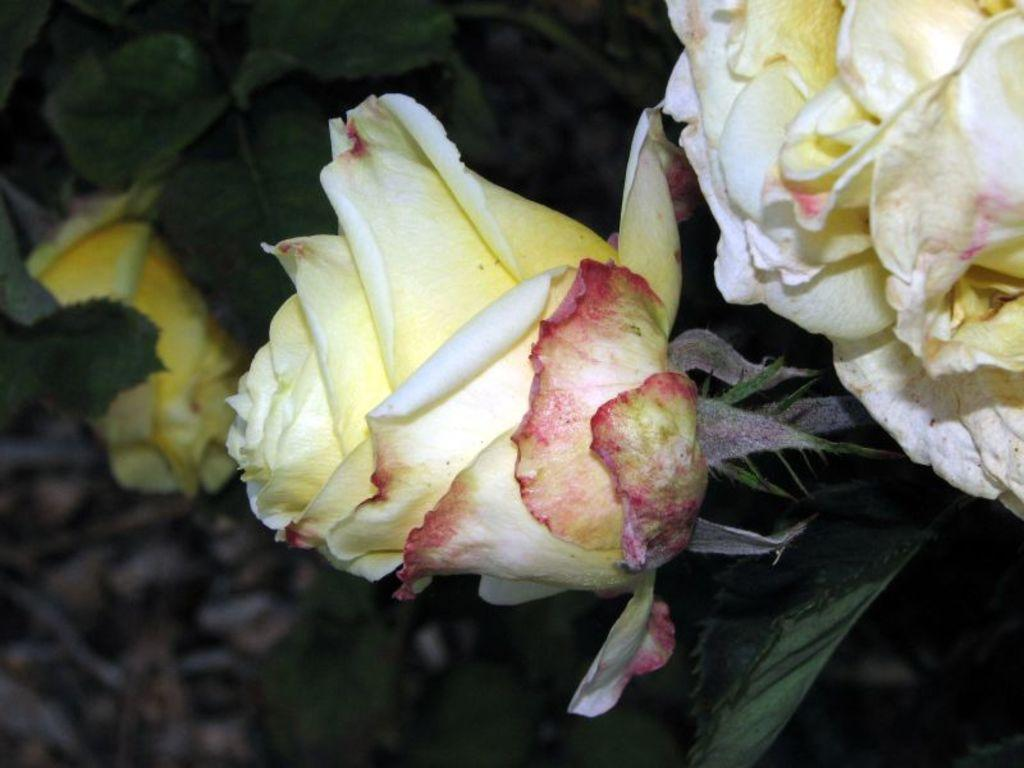What type of plant life is present in the image? There are flowers with stems and leaves in the image. Where are the flowers located in the image? The flowers are in the middle of the image. What else can be seen in the background of the image? There are other leaves visible in the background of the image. What type of engine is visible in the image? There is no engine present in the image; it features flowers and leaves. What kind of discussion is taking place in the image? There is no discussion taking place in the image; it is a still image of flowers and leaves. 